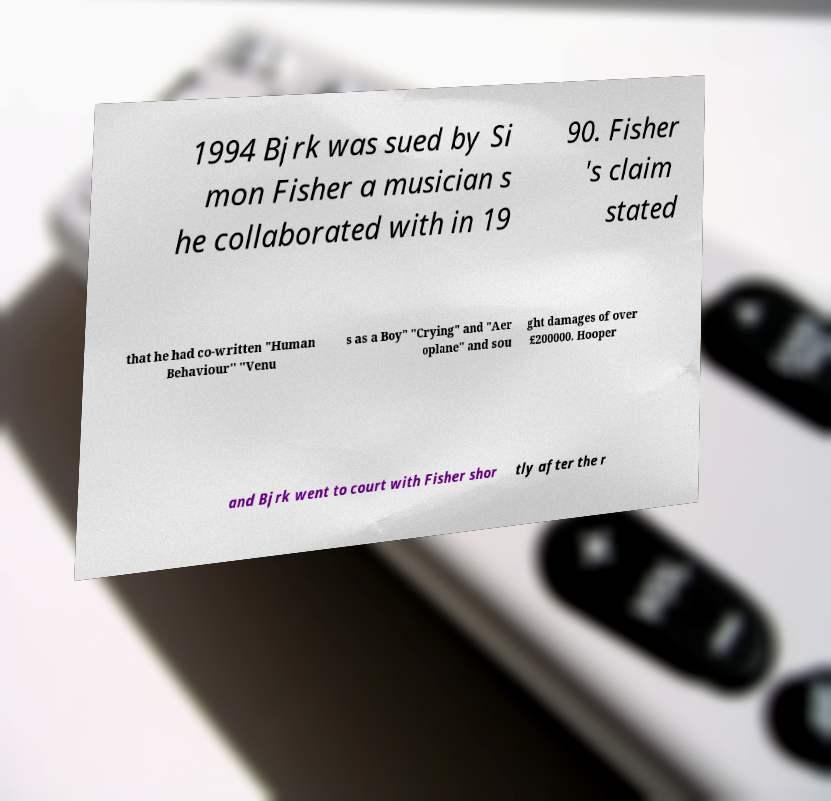There's text embedded in this image that I need extracted. Can you transcribe it verbatim? 1994 Bjrk was sued by Si mon Fisher a musician s he collaborated with in 19 90. Fisher 's claim stated that he had co-written "Human Behaviour" "Venu s as a Boy" "Crying" and "Aer oplane" and sou ght damages of over £200000. Hooper and Bjrk went to court with Fisher shor tly after the r 